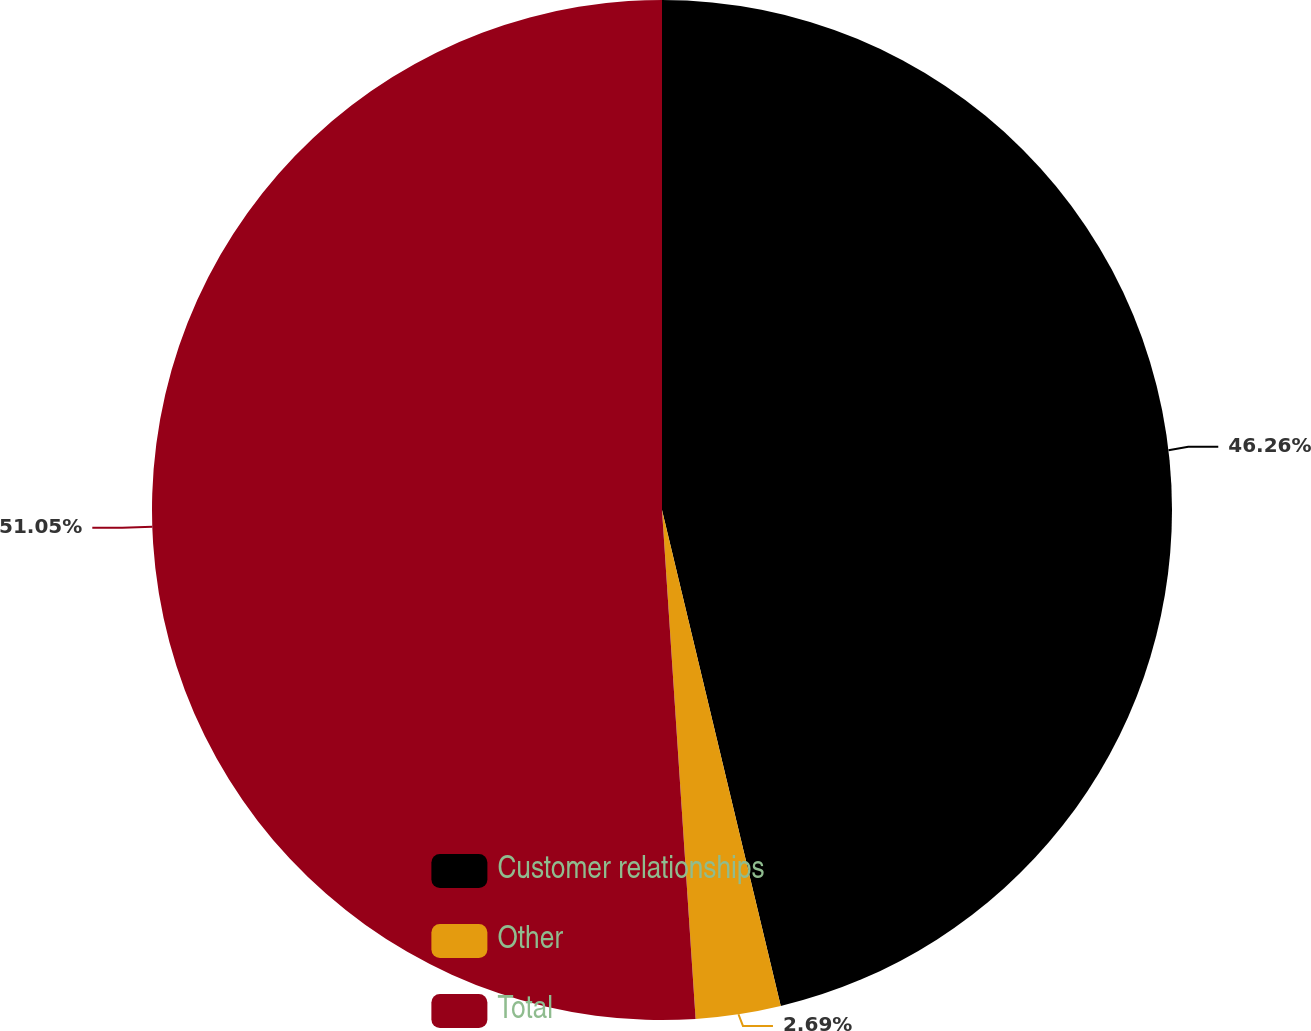Convert chart to OTSL. <chart><loc_0><loc_0><loc_500><loc_500><pie_chart><fcel>Customer relationships<fcel>Other<fcel>Total<nl><fcel>46.26%<fcel>2.69%<fcel>51.05%<nl></chart> 